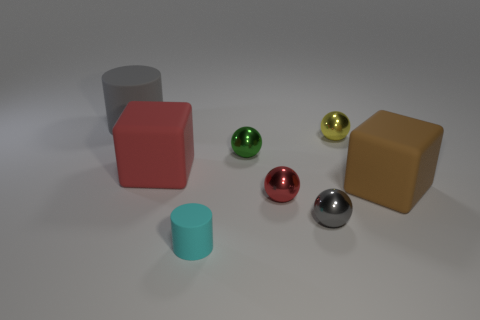Add 1 cyan rubber cylinders. How many objects exist? 9 Subtract all cylinders. How many objects are left? 6 Add 6 red balls. How many red balls exist? 7 Subtract 0 blue spheres. How many objects are left? 8 Subtract all tiny gray objects. Subtract all brown cubes. How many objects are left? 6 Add 3 tiny gray objects. How many tiny gray objects are left? 4 